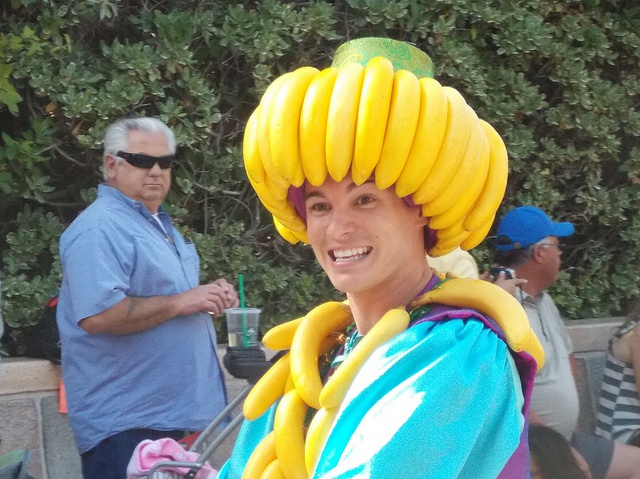Describe the objects in this image and their specific colors. I can see people in black, gold, cyan, khaki, and orange tones, people in black, gray, darkgray, and lightblue tones, banana in black, gold, orange, and khaki tones, people in black, darkgray, gray, blue, and brown tones, and people in black and gray tones in this image. 